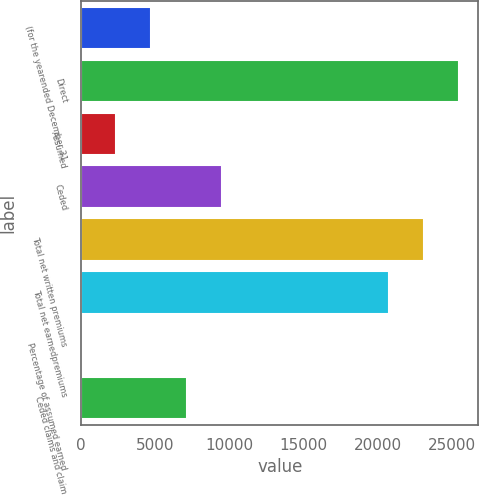Convert chart to OTSL. <chart><loc_0><loc_0><loc_500><loc_500><bar_chart><fcel>(for the yearended December 31<fcel>Direct<fcel>Assumed<fcel>Ceded<fcel>Total net written premiums<fcel>Total net earnedpremiums<fcel>Percentage of assumed earned<fcel>Ceded claims and claim<nl><fcel>4728.84<fcel>25486.5<fcel>2365.57<fcel>9455.38<fcel>23123.3<fcel>20760<fcel>2.3<fcel>7092.11<nl></chart> 